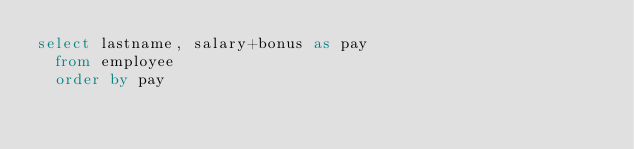<code> <loc_0><loc_0><loc_500><loc_500><_SQL_>select lastname, salary+bonus as pay
  from employee
  order by pay</code> 